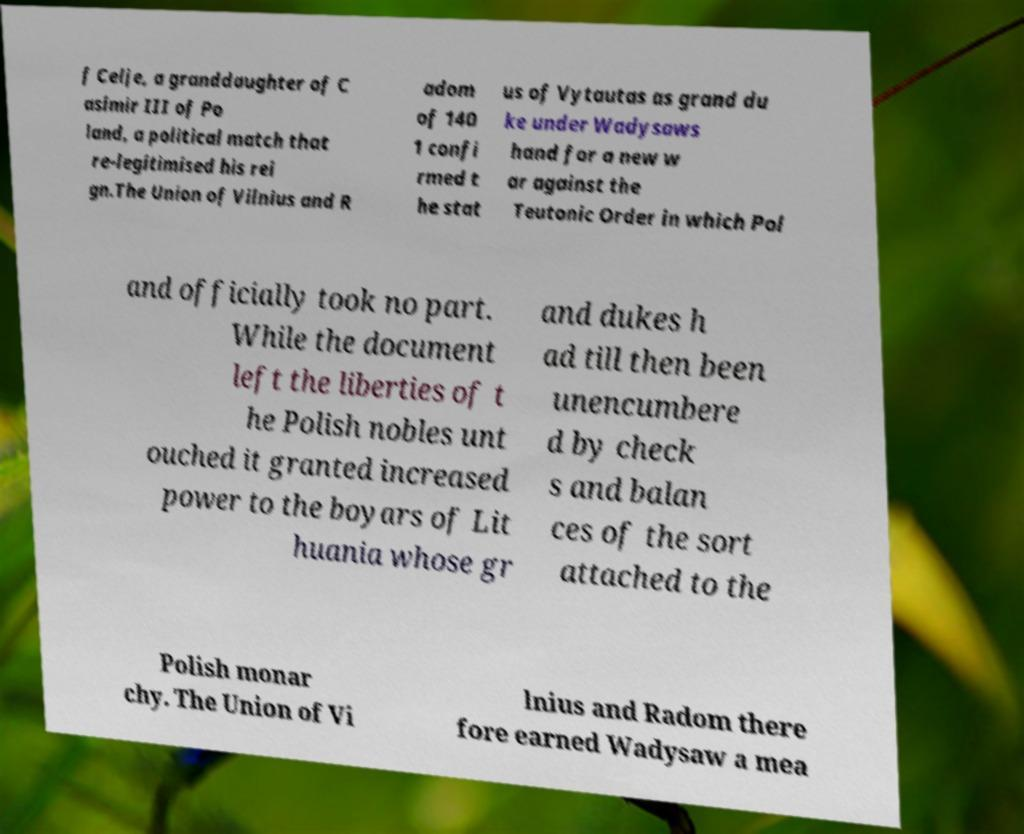Please read and relay the text visible in this image. What does it say? f Celje, a granddaughter of C asimir III of Po land, a political match that re-legitimised his rei gn.The Union of Vilnius and R adom of 140 1 confi rmed t he stat us of Vytautas as grand du ke under Wadysaws hand for a new w ar against the Teutonic Order in which Pol and officially took no part. While the document left the liberties of t he Polish nobles unt ouched it granted increased power to the boyars of Lit huania whose gr and dukes h ad till then been unencumbere d by check s and balan ces of the sort attached to the Polish monar chy. The Union of Vi lnius and Radom there fore earned Wadysaw a mea 